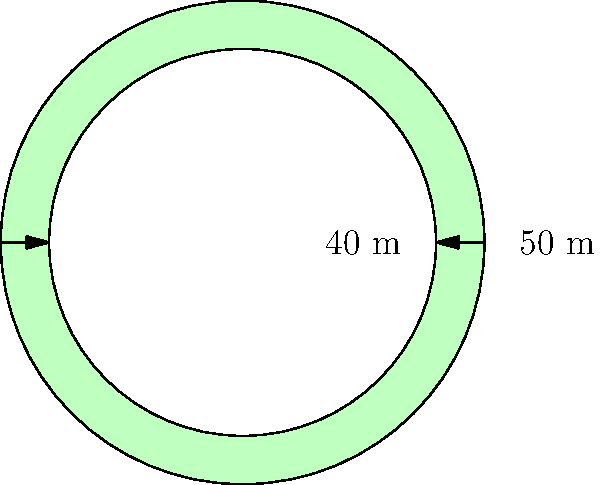In the Vatican Gardens, a circular running track has been constructed. The outer radius of the track is 50 meters, while the inner radius is 40 meters. What is the area of the running surface? To find the area of the running surface, we need to:

1. Calculate the area of the larger circle (outer boundary):
   $$A_{outer} = \pi r_{outer}^2 = \pi (50\,\text{m})^2 = 2500\pi\,\text{m}^2$$

2. Calculate the area of the smaller circle (inner boundary):
   $$A_{inner} = \pi r_{inner}^2 = \pi (40\,\text{m})^2 = 1600\pi\,\text{m}^2$$

3. Subtract the area of the inner circle from the area of the outer circle:
   $$A_{track} = A_{outer} - A_{inner} = 2500\pi\,\text{m}^2 - 1600\pi\,\text{m}^2 = 900\pi\,\text{m}^2$$

4. Simplify:
   $$A_{track} = 900\pi\,\text{m}^2 \approx 2827.43\,\text{m}^2$$

Therefore, the area of the running surface is $900\pi\,\text{m}^2$ or approximately $2827.43\,\text{m}^2$.
Answer: $900\pi\,\text{m}^2$ 